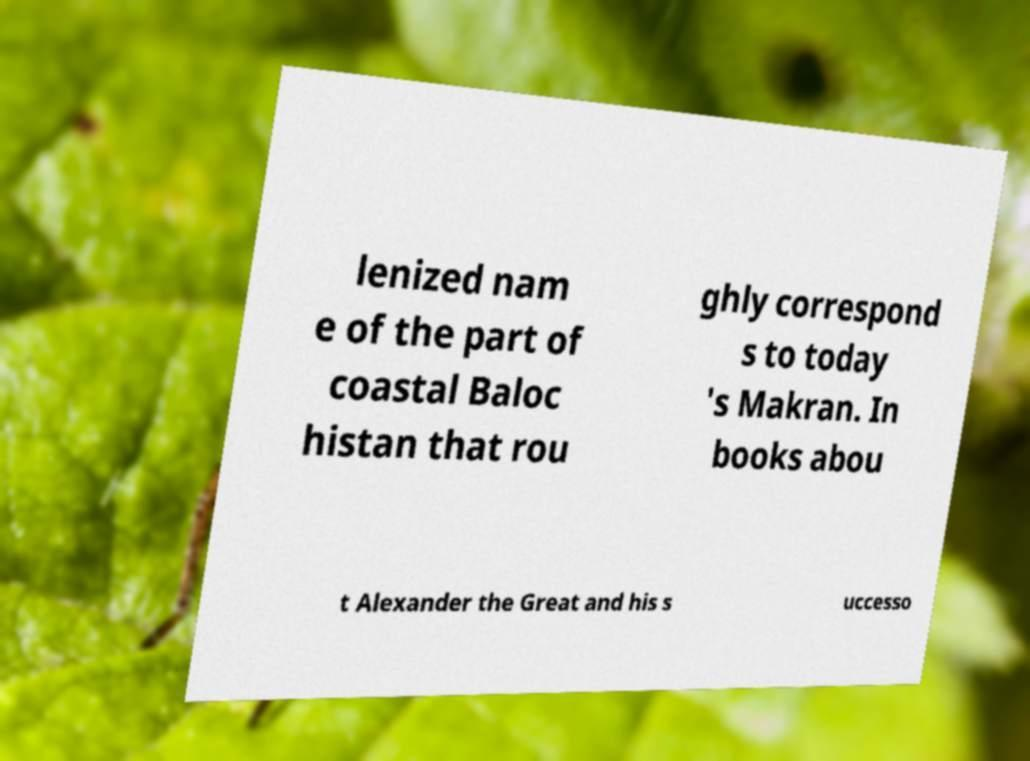Please identify and transcribe the text found in this image. lenized nam e of the part of coastal Baloc histan that rou ghly correspond s to today 's Makran. In books abou t Alexander the Great and his s uccesso 